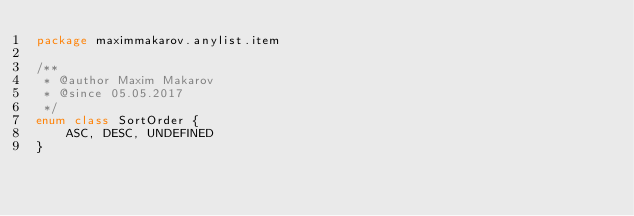<code> <loc_0><loc_0><loc_500><loc_500><_Kotlin_>package maximmakarov.anylist.item

/**
 * @author Maxim Makarov
 * @since 05.05.2017
 */
enum class SortOrder {
    ASC, DESC, UNDEFINED
}</code> 